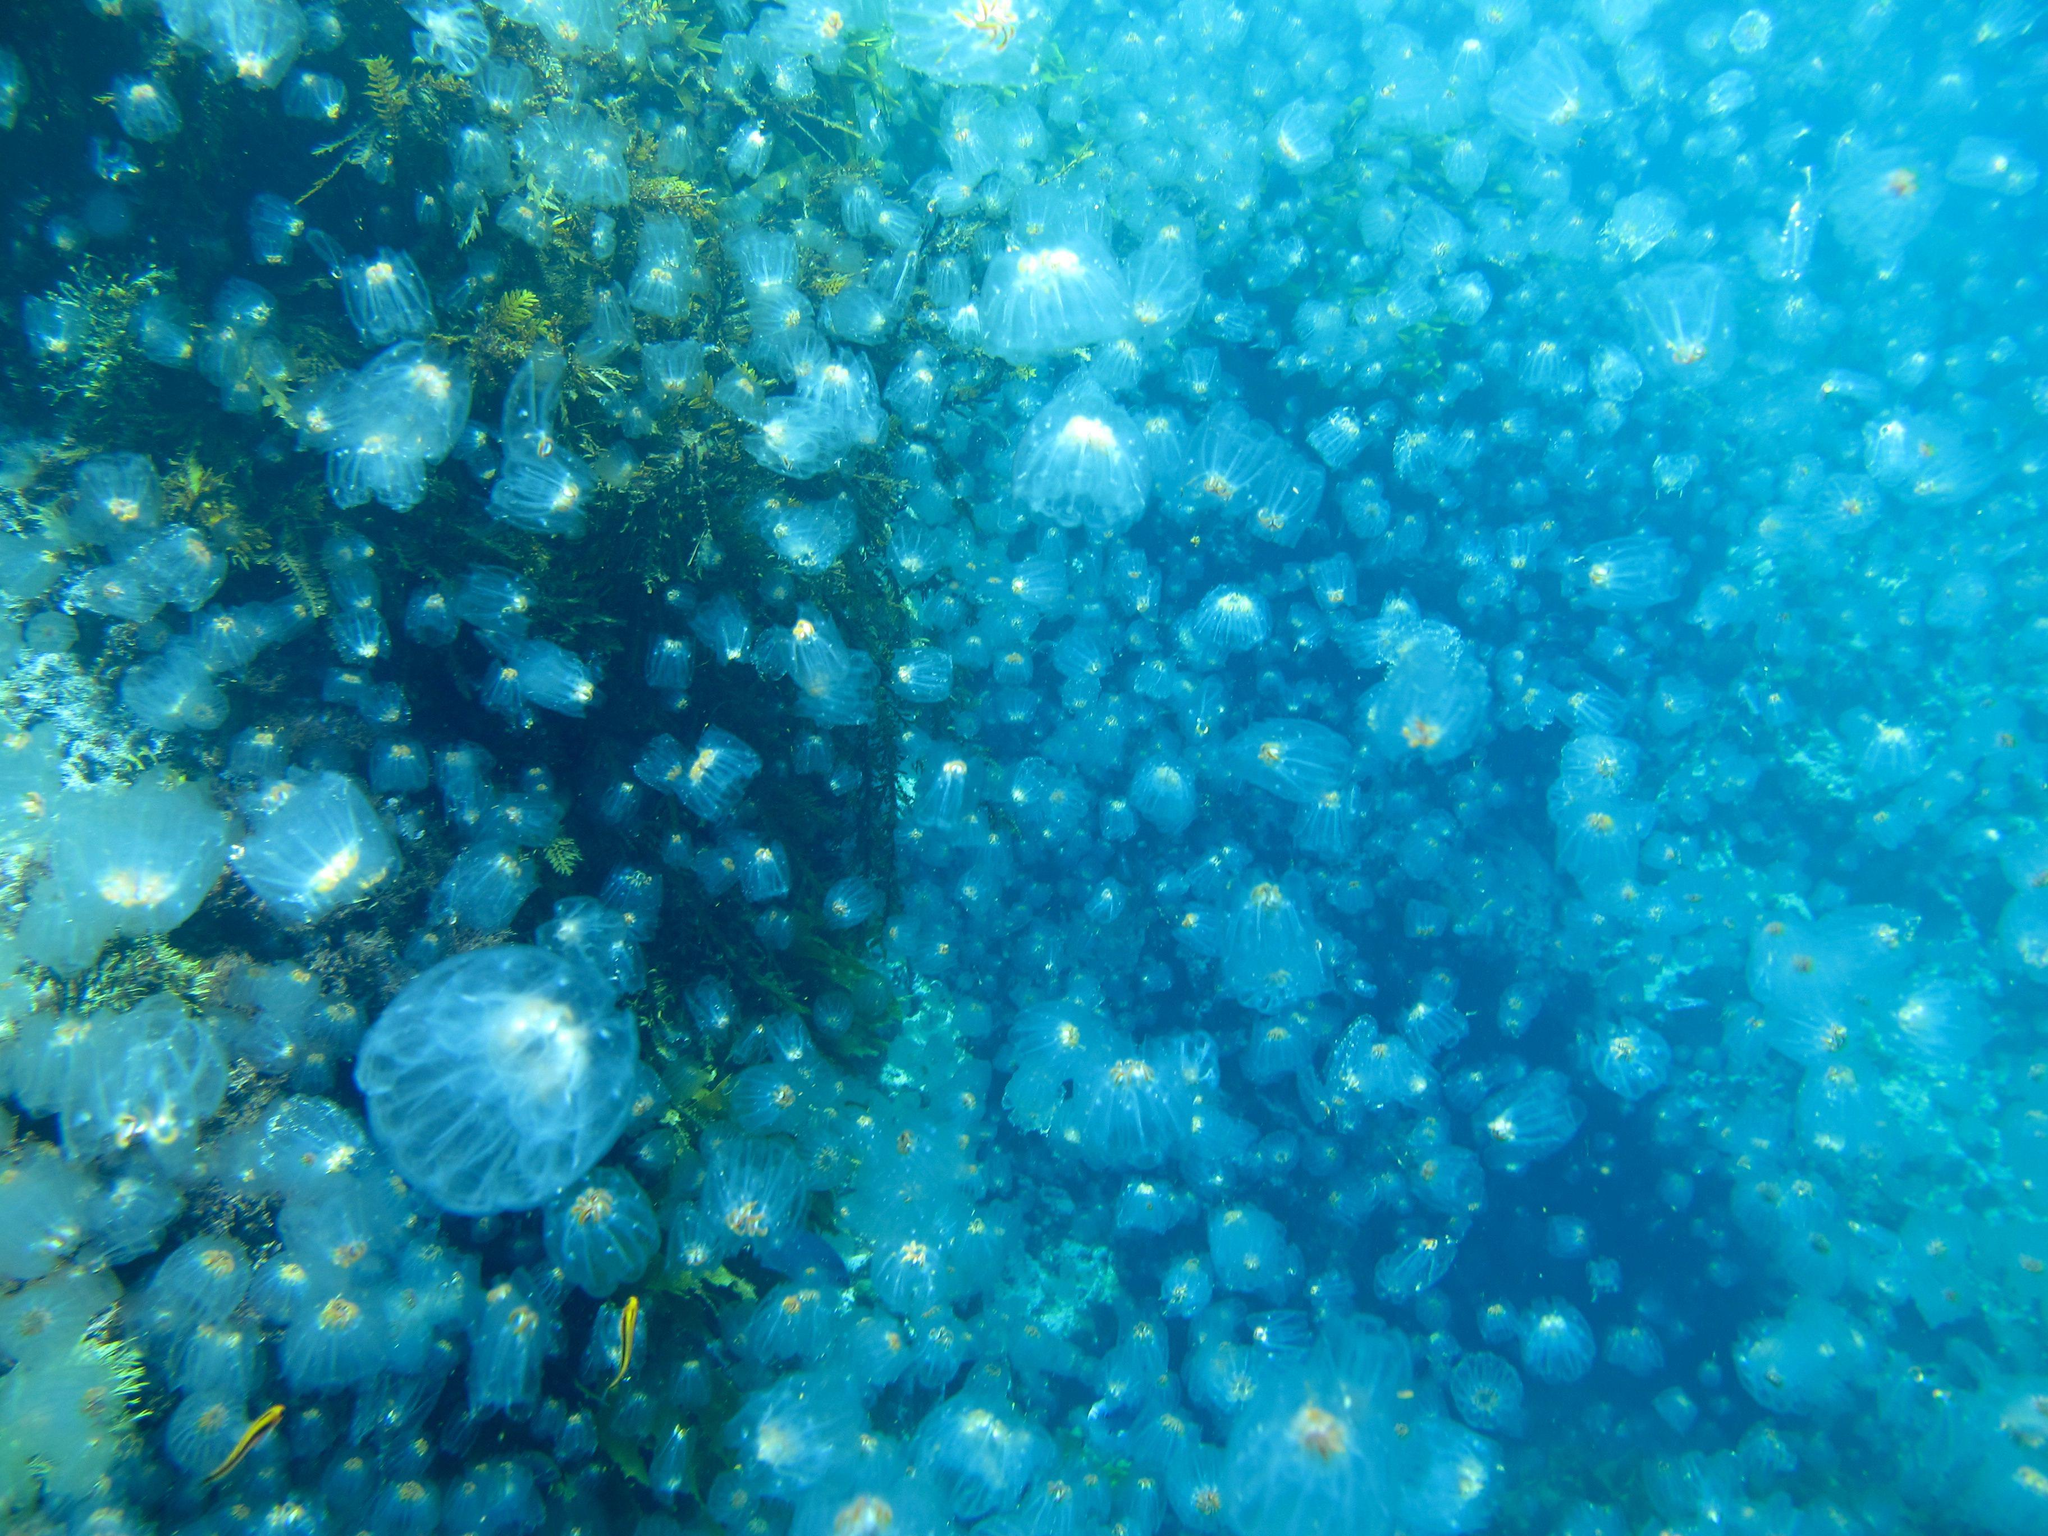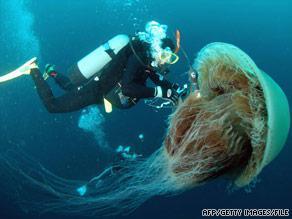The first image is the image on the left, the second image is the image on the right. Considering the images on both sides, is "There are at least one hundred light orange jellyfish in the iamge on the left" valid? Answer yes or no. No. 